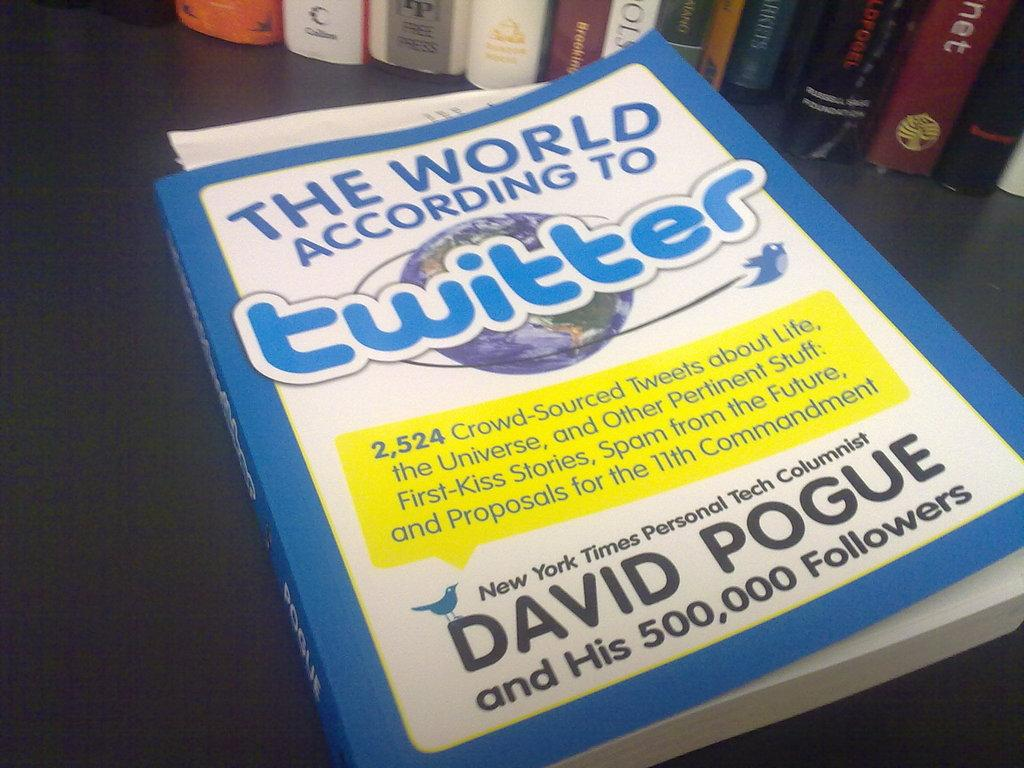Provide a one-sentence caption for the provided image. Book about the world according to twiiter by David Pogue. 